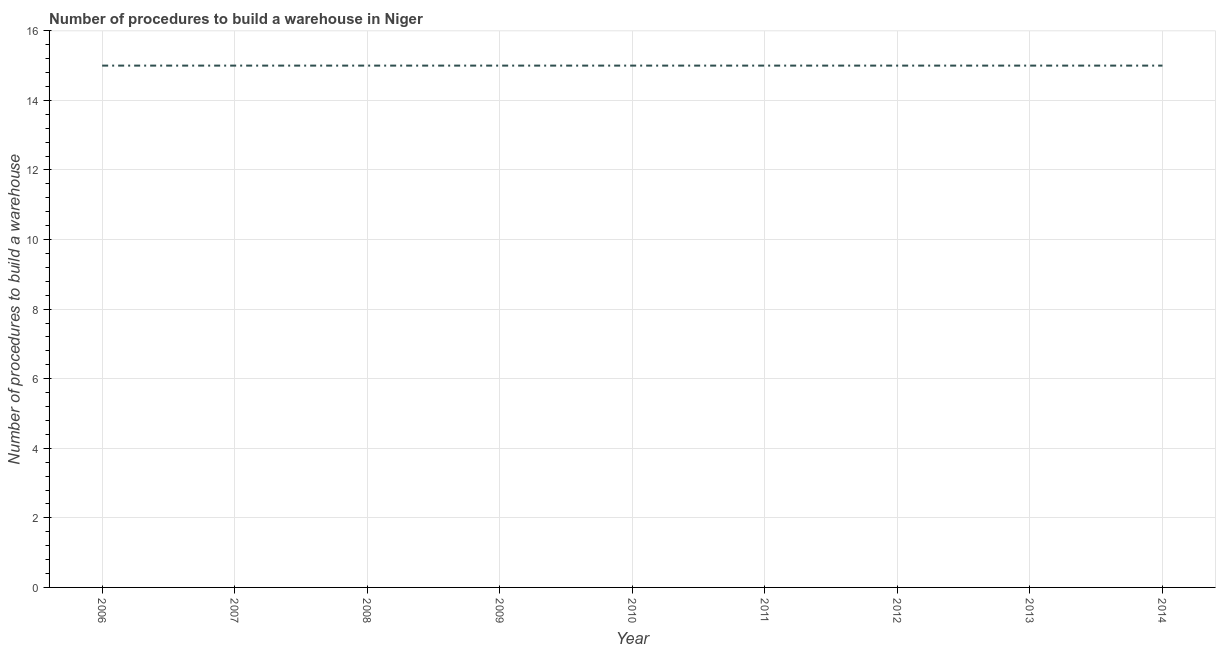What is the number of procedures to build a warehouse in 2006?
Your answer should be very brief. 15. Across all years, what is the maximum number of procedures to build a warehouse?
Make the answer very short. 15. Across all years, what is the minimum number of procedures to build a warehouse?
Your answer should be compact. 15. In which year was the number of procedures to build a warehouse minimum?
Give a very brief answer. 2006. What is the sum of the number of procedures to build a warehouse?
Your response must be concise. 135. What is the average number of procedures to build a warehouse per year?
Provide a short and direct response. 15. What is the median number of procedures to build a warehouse?
Your answer should be very brief. 15. Is the number of procedures to build a warehouse in 2007 less than that in 2014?
Your response must be concise. No. What is the difference between the highest and the lowest number of procedures to build a warehouse?
Offer a terse response. 0. In how many years, is the number of procedures to build a warehouse greater than the average number of procedures to build a warehouse taken over all years?
Offer a very short reply. 0. Does the number of procedures to build a warehouse monotonically increase over the years?
Provide a short and direct response. No. How many lines are there?
Give a very brief answer. 1. What is the difference between two consecutive major ticks on the Y-axis?
Give a very brief answer. 2. Are the values on the major ticks of Y-axis written in scientific E-notation?
Provide a short and direct response. No. What is the title of the graph?
Your answer should be compact. Number of procedures to build a warehouse in Niger. What is the label or title of the X-axis?
Your answer should be compact. Year. What is the label or title of the Y-axis?
Ensure brevity in your answer.  Number of procedures to build a warehouse. What is the Number of procedures to build a warehouse of 2006?
Your answer should be very brief. 15. What is the Number of procedures to build a warehouse in 2007?
Offer a terse response. 15. What is the Number of procedures to build a warehouse of 2008?
Offer a terse response. 15. What is the Number of procedures to build a warehouse of 2009?
Offer a terse response. 15. What is the Number of procedures to build a warehouse of 2011?
Ensure brevity in your answer.  15. What is the Number of procedures to build a warehouse of 2012?
Provide a succinct answer. 15. What is the Number of procedures to build a warehouse in 2013?
Keep it short and to the point. 15. What is the difference between the Number of procedures to build a warehouse in 2006 and 2007?
Offer a terse response. 0. What is the difference between the Number of procedures to build a warehouse in 2006 and 2008?
Offer a very short reply. 0. What is the difference between the Number of procedures to build a warehouse in 2006 and 2009?
Give a very brief answer. 0. What is the difference between the Number of procedures to build a warehouse in 2006 and 2010?
Provide a short and direct response. 0. What is the difference between the Number of procedures to build a warehouse in 2006 and 2012?
Make the answer very short. 0. What is the difference between the Number of procedures to build a warehouse in 2006 and 2013?
Your answer should be compact. 0. What is the difference between the Number of procedures to build a warehouse in 2006 and 2014?
Your answer should be compact. 0. What is the difference between the Number of procedures to build a warehouse in 2007 and 2009?
Your response must be concise. 0. What is the difference between the Number of procedures to build a warehouse in 2007 and 2012?
Provide a short and direct response. 0. What is the difference between the Number of procedures to build a warehouse in 2007 and 2013?
Ensure brevity in your answer.  0. What is the difference between the Number of procedures to build a warehouse in 2008 and 2009?
Your answer should be very brief. 0. What is the difference between the Number of procedures to build a warehouse in 2008 and 2010?
Offer a very short reply. 0. What is the difference between the Number of procedures to build a warehouse in 2009 and 2011?
Provide a succinct answer. 0. What is the difference between the Number of procedures to build a warehouse in 2009 and 2014?
Your response must be concise. 0. What is the difference between the Number of procedures to build a warehouse in 2010 and 2012?
Provide a short and direct response. 0. What is the difference between the Number of procedures to build a warehouse in 2010 and 2014?
Give a very brief answer. 0. What is the difference between the Number of procedures to build a warehouse in 2011 and 2012?
Give a very brief answer. 0. What is the difference between the Number of procedures to build a warehouse in 2012 and 2013?
Offer a terse response. 0. What is the difference between the Number of procedures to build a warehouse in 2012 and 2014?
Provide a short and direct response. 0. What is the ratio of the Number of procedures to build a warehouse in 2006 to that in 2007?
Offer a very short reply. 1. What is the ratio of the Number of procedures to build a warehouse in 2006 to that in 2008?
Offer a terse response. 1. What is the ratio of the Number of procedures to build a warehouse in 2006 to that in 2010?
Give a very brief answer. 1. What is the ratio of the Number of procedures to build a warehouse in 2007 to that in 2008?
Your answer should be compact. 1. What is the ratio of the Number of procedures to build a warehouse in 2007 to that in 2011?
Provide a short and direct response. 1. What is the ratio of the Number of procedures to build a warehouse in 2007 to that in 2012?
Your response must be concise. 1. What is the ratio of the Number of procedures to build a warehouse in 2007 to that in 2013?
Ensure brevity in your answer.  1. What is the ratio of the Number of procedures to build a warehouse in 2008 to that in 2011?
Your answer should be very brief. 1. What is the ratio of the Number of procedures to build a warehouse in 2008 to that in 2012?
Your answer should be very brief. 1. What is the ratio of the Number of procedures to build a warehouse in 2008 to that in 2013?
Provide a succinct answer. 1. What is the ratio of the Number of procedures to build a warehouse in 2009 to that in 2014?
Provide a succinct answer. 1. What is the ratio of the Number of procedures to build a warehouse in 2010 to that in 2011?
Keep it short and to the point. 1. What is the ratio of the Number of procedures to build a warehouse in 2010 to that in 2012?
Keep it short and to the point. 1. What is the ratio of the Number of procedures to build a warehouse in 2010 to that in 2013?
Provide a short and direct response. 1. What is the ratio of the Number of procedures to build a warehouse in 2011 to that in 2012?
Your answer should be compact. 1. What is the ratio of the Number of procedures to build a warehouse in 2011 to that in 2013?
Provide a short and direct response. 1. What is the ratio of the Number of procedures to build a warehouse in 2011 to that in 2014?
Make the answer very short. 1. 